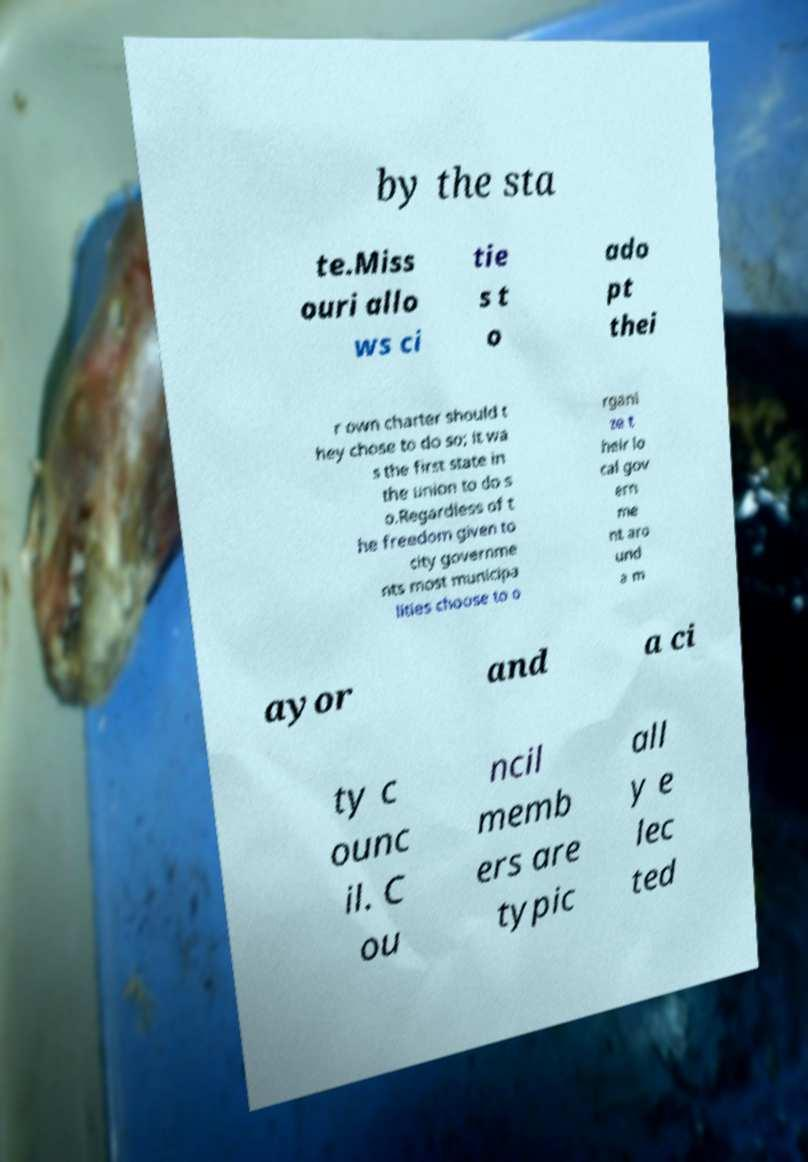Please identify and transcribe the text found in this image. by the sta te.Miss ouri allo ws ci tie s t o ado pt thei r own charter should t hey chose to do so; it wa s the first state in the union to do s o.Regardless of t he freedom given to city governme nts most municipa lities choose to o rgani ze t heir lo cal gov ern me nt aro und a m ayor and a ci ty c ounc il. C ou ncil memb ers are typic all y e lec ted 